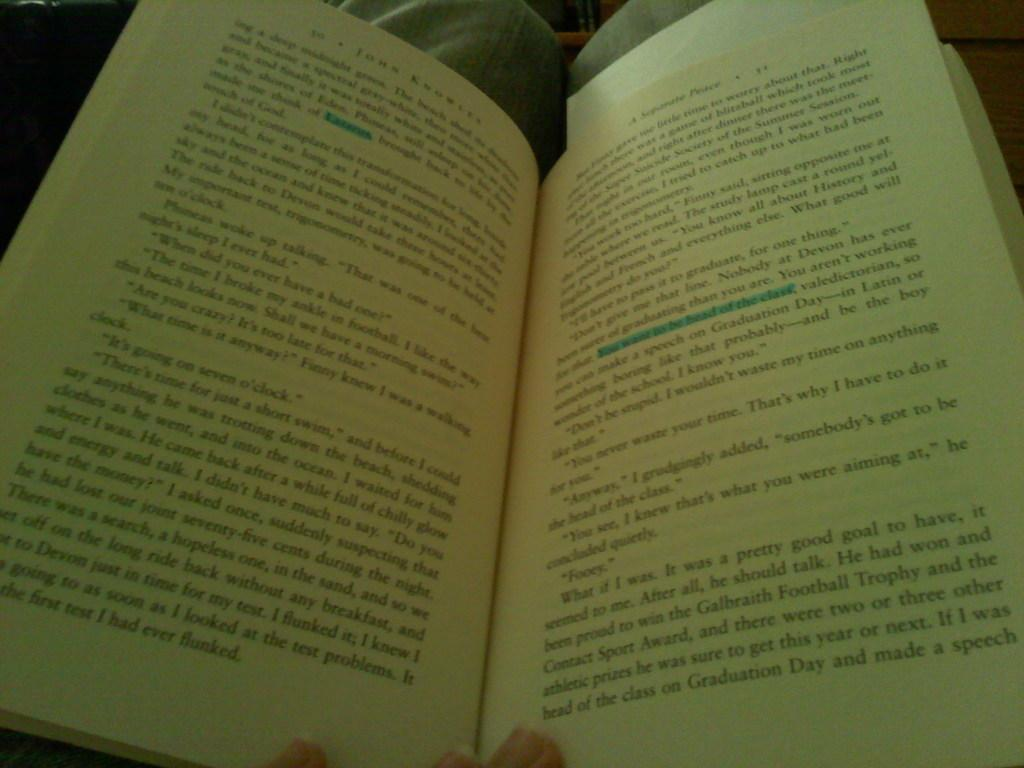<image>
Provide a brief description of the given image. In an opened book, the line "You want to be head of the class" is highlighted. 